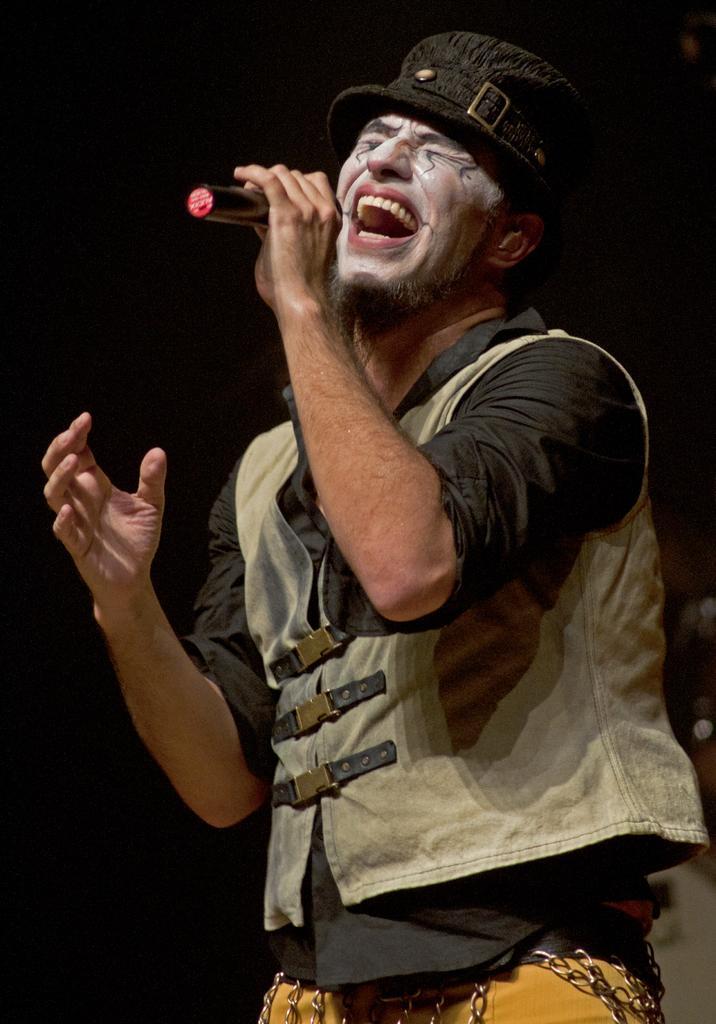Could you give a brief overview of what you see in this image? This picture shows a man standing and singing with the help of a microphone in his hand and he wore a cap on his head and a coat. 